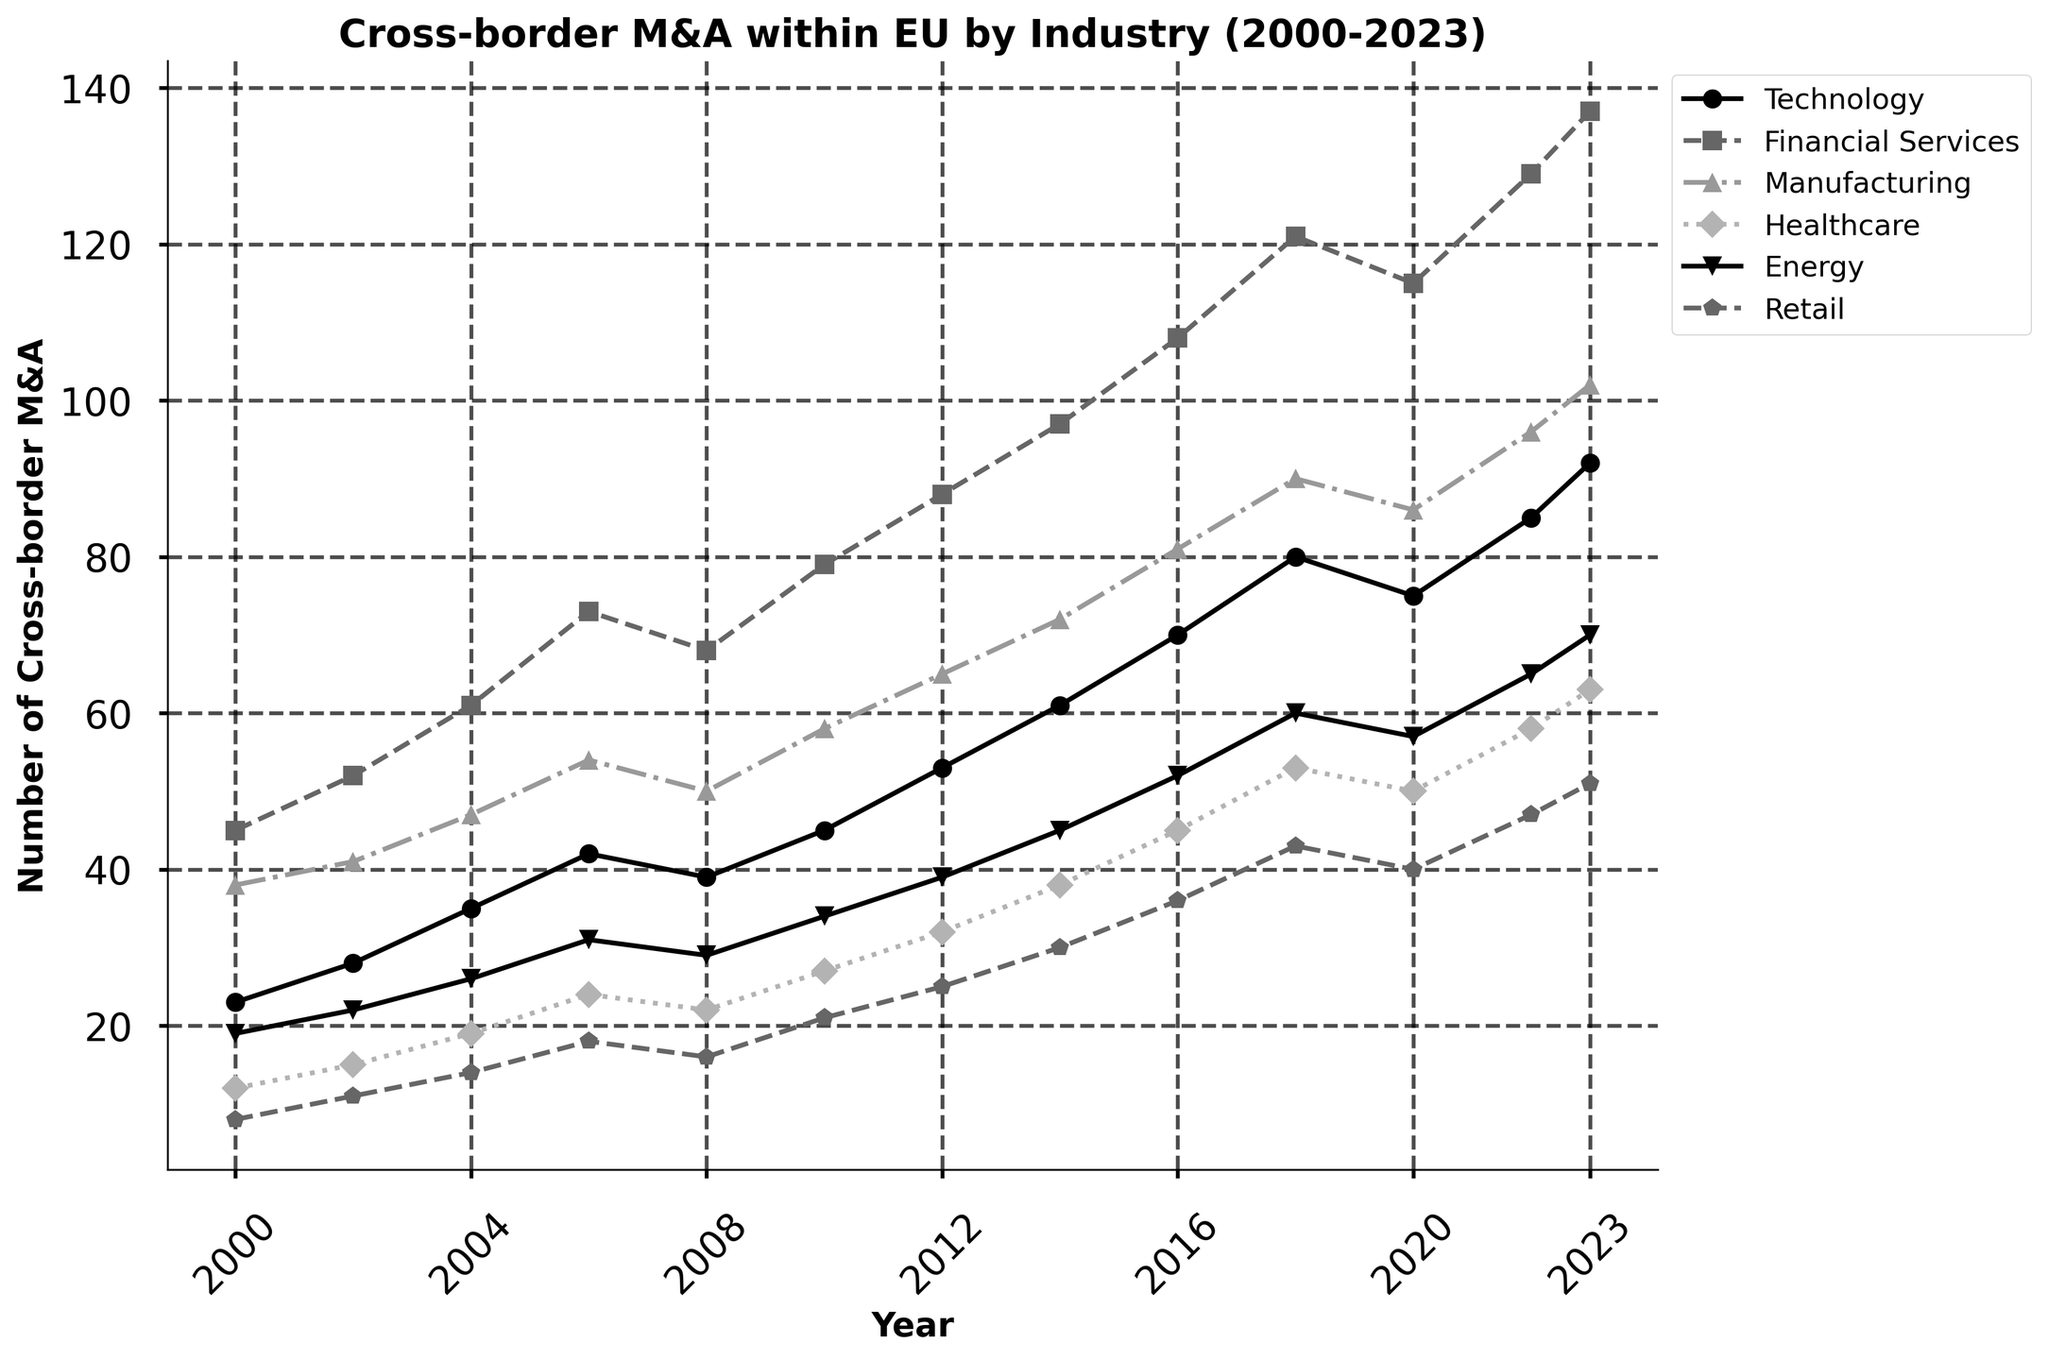What is the overall trend of cross-border mergers and acquisitions in the Technology sector from 2000 to 2023? By observing the line representing the Technology sector, we see a consistent upward trend from 23 in 2000 to 92 in 2023.
Answer: Increasing Which industry had the highest number of cross-border M&A in 2023? By comparing the data points for 2023 across all industries, the Financial Services sector had the highest number with 137 cross-border M&A.
Answer: Financial Services In which year did the number of cross-border M&A in the Retail sector first exceed 40? By examining the Retail sector data line, it first exceeded 40 in the year 2018, where it was 43.
Answer: 2018 How much did the number of cross-border M&A in the Manufacturing sector change from 2000 to 2023? The Manufacturing sector had 38 cross-border M&A in 2000 and 102 in 2023. The change is 102 - 38 = 64.
Answer: 64 Which sector saw the smallest increase in the number of cross-border M&A from 2000 to 2023? By calculating the differences for each sector, Retail had an increase from 8 to 51, a difference of 43, which is the smallest increase among all sectors.
Answer: Retail Compare the number of cross-border M&A in Healthcare and Energy sectors in 2010. Which one was higher and by how much? In 2010, Healthcare had 27, and Energy had 34 cross-border M&A. Energy was higher by 34 - 27 = 7.
Answer: Energy by 7 In which year did the Technology and Energy sectors have the same number of cross-border M&A? From the data, in the year 2008, both Technology and Energy sectors had cross-border M&A of 39.
Answer: 2008 What is the average number of cross-border M&A in the Financial Services sector over the years 2000, 2010, and 2023? The numbers for these years are 45, 79, and 137. The average is (45 + 79 + 137) / 3 = 87.
Answer: 87 What was the percentage increase in cross-border M&A for the Healthcare sector from 2002 to 2022? In 2002, Healthcare had 15 cross-border M&A, and in 2022, it had 58. The percentage increase is ((58 - 15) / 15) * 100 = 286.67%.
Answer: 286.67% Between 2006 and 2020, which sector experienced the most significant rise in cross-border M&A numbers, and what was the increase? We calculate the change for each sector: 
- Technology: 75 - 42 = 33
- Financial Services: 115 - 73 = 42
- Manufacturing: 86 - 54 = 32
- Healthcare: 50 - 24 = 26
- Energy: 57 - 31 = 26
- Retail: 40 - 18 = 22
The Financial Services sector experienced the most significant rise with an increase of 42.
Answer: Financial Services by 42 